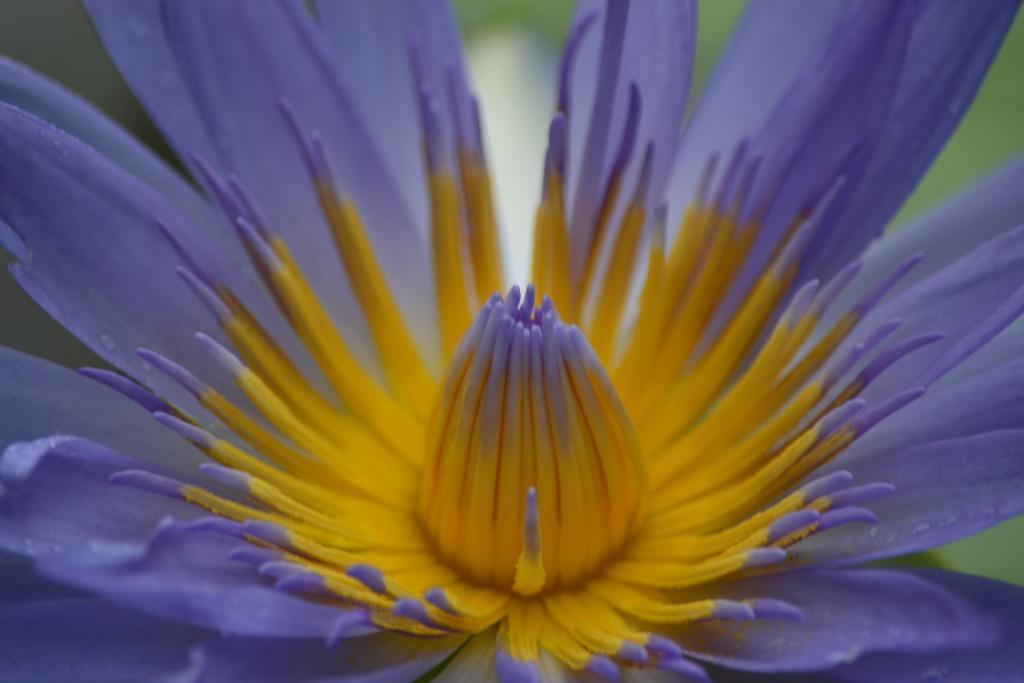What is the main subject of the image? There is a flower in the image. Can you describe the background of the image? The background of the image is blurred. What hobbies does the girl in the image enjoy? There is no girl present in the image; it features a flower. 